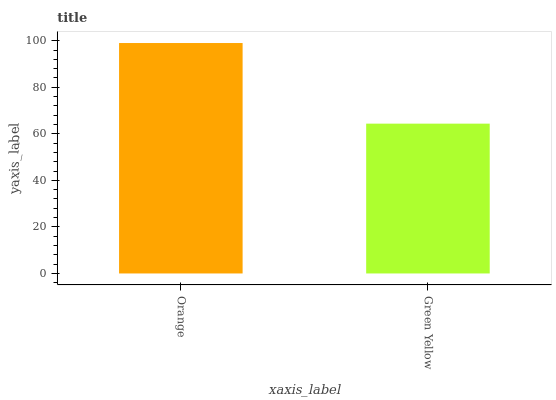Is Green Yellow the minimum?
Answer yes or no. Yes. Is Orange the maximum?
Answer yes or no. Yes. Is Green Yellow the maximum?
Answer yes or no. No. Is Orange greater than Green Yellow?
Answer yes or no. Yes. Is Green Yellow less than Orange?
Answer yes or no. Yes. Is Green Yellow greater than Orange?
Answer yes or no. No. Is Orange less than Green Yellow?
Answer yes or no. No. Is Orange the high median?
Answer yes or no. Yes. Is Green Yellow the low median?
Answer yes or no. Yes. Is Green Yellow the high median?
Answer yes or no. No. Is Orange the low median?
Answer yes or no. No. 